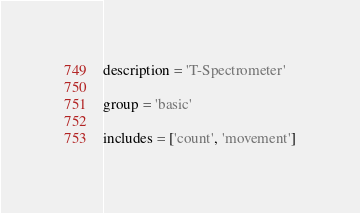<code> <loc_0><loc_0><loc_500><loc_500><_Python_>description = 'T-Spectrometer'

group = 'basic'

includes = ['count', 'movement']
</code> 